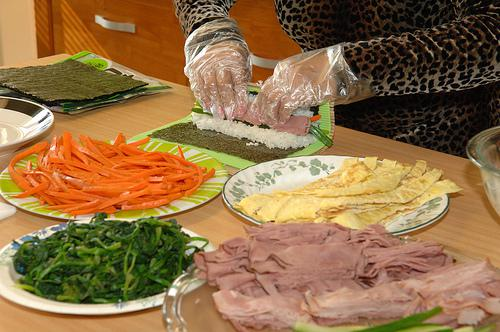Question: what is she doing?
Choices:
A. Making sushi.
B. Cleaning house.
C. Walking a dog.
D. Watching television.
Answer with the letter. Answer: A Question: when is the picture taken?
Choices:
A. Lunch time.
B. Before the food is served.
C. Afternoon.
D. 11:39pm.
Answer with the letter. Answer: B Question: why is the woman wearing gloves?
Choices:
A. Weather is cold.
B. Protect them from chemicals.
C. To not make a mes.
D. Fashion statement.
Answer with the letter. Answer: C Question: what is white in the sushi?
Choices:
A. Fish meat.
B. Paper napkin.
C. Vegetable.
D. Rice.
Answer with the letter. Answer: D Question: who is in the kitchen?
Choices:
A. A woman.
B. The family.
C. 2 girls.
D. Father and son.
Answer with the letter. Answer: A 